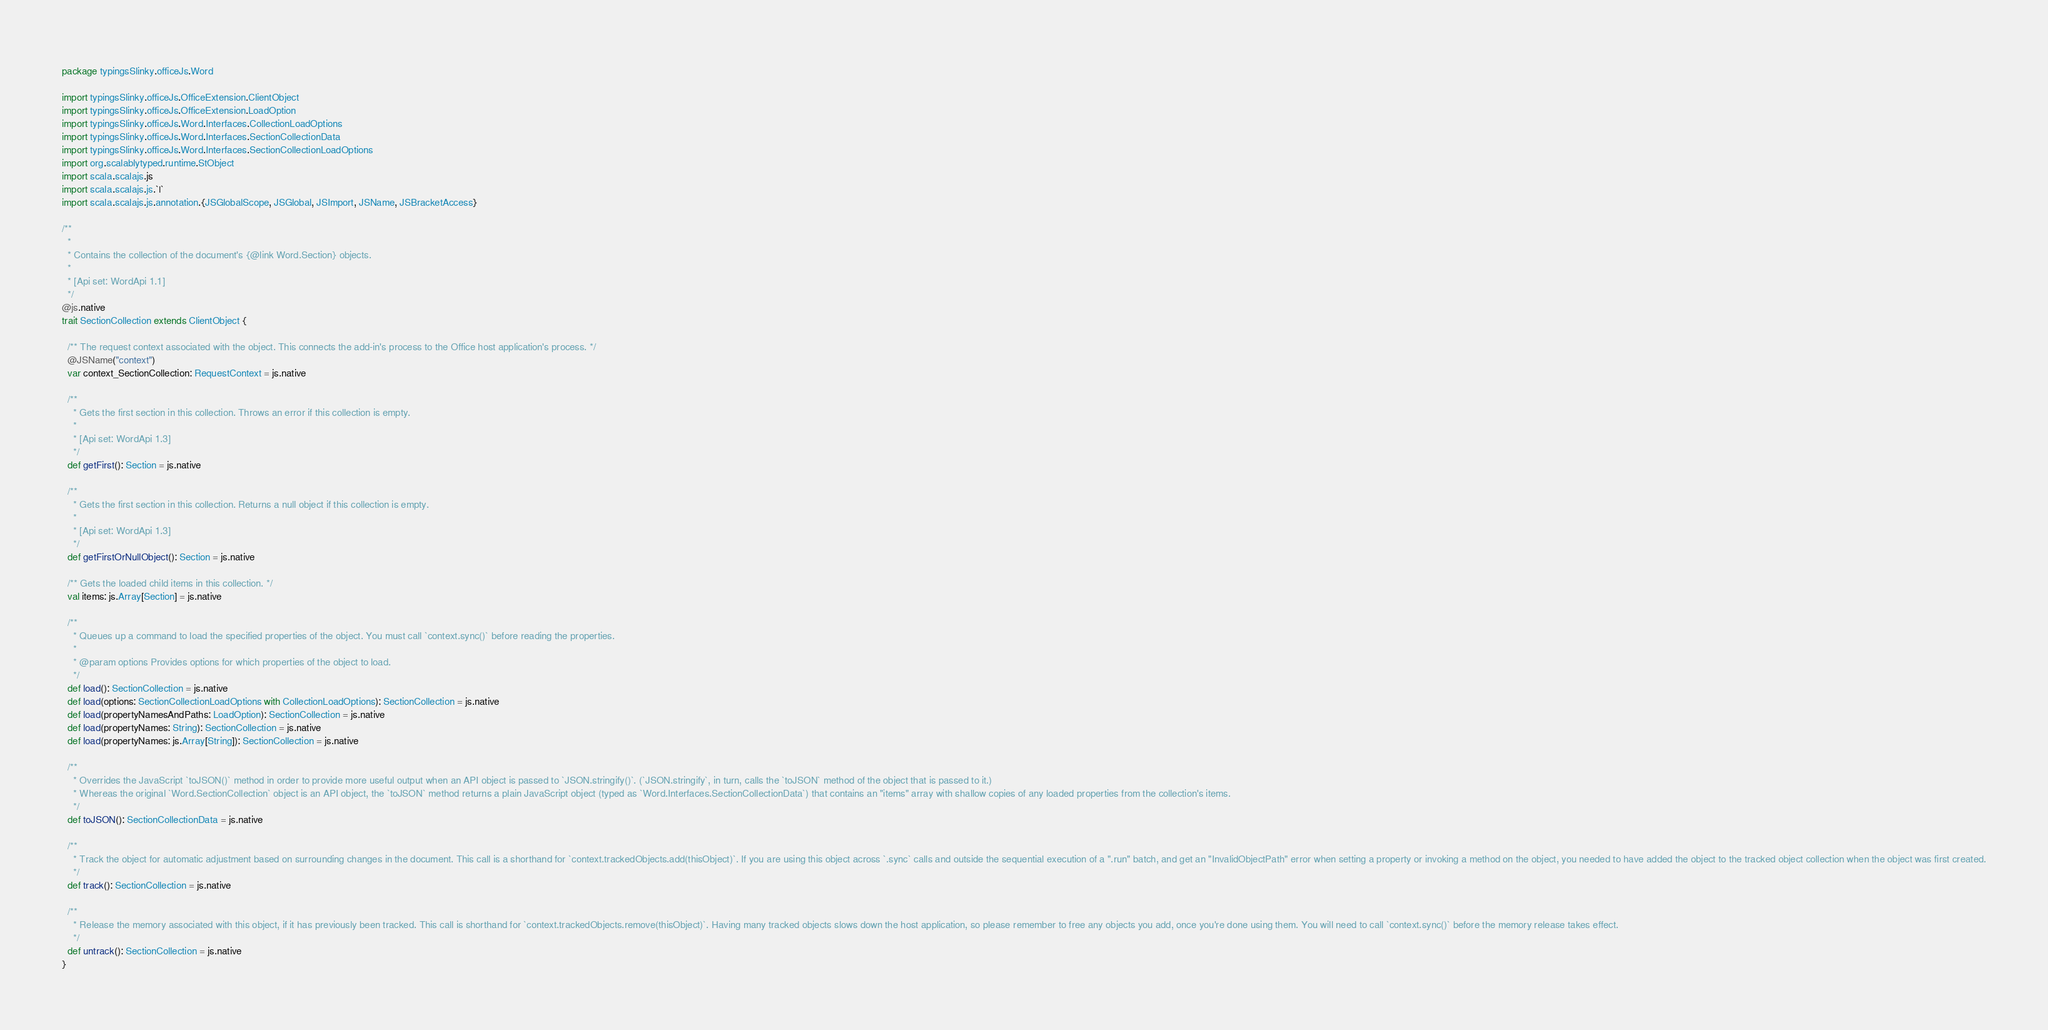Convert code to text. <code><loc_0><loc_0><loc_500><loc_500><_Scala_>package typingsSlinky.officeJs.Word

import typingsSlinky.officeJs.OfficeExtension.ClientObject
import typingsSlinky.officeJs.OfficeExtension.LoadOption
import typingsSlinky.officeJs.Word.Interfaces.CollectionLoadOptions
import typingsSlinky.officeJs.Word.Interfaces.SectionCollectionData
import typingsSlinky.officeJs.Word.Interfaces.SectionCollectionLoadOptions
import org.scalablytyped.runtime.StObject
import scala.scalajs.js
import scala.scalajs.js.`|`
import scala.scalajs.js.annotation.{JSGlobalScope, JSGlobal, JSImport, JSName, JSBracketAccess}

/**
  *
  * Contains the collection of the document's {@link Word.Section} objects.
  *
  * [Api set: WordApi 1.1]
  */
@js.native
trait SectionCollection extends ClientObject {
  
  /** The request context associated with the object. This connects the add-in's process to the Office host application's process. */
  @JSName("context")
  var context_SectionCollection: RequestContext = js.native
  
  /**
    * Gets the first section in this collection. Throws an error if this collection is empty.
    *
    * [Api set: WordApi 1.3]
    */
  def getFirst(): Section = js.native
  
  /**
    * Gets the first section in this collection. Returns a null object if this collection is empty.
    *
    * [Api set: WordApi 1.3]
    */
  def getFirstOrNullObject(): Section = js.native
  
  /** Gets the loaded child items in this collection. */
  val items: js.Array[Section] = js.native
  
  /**
    * Queues up a command to load the specified properties of the object. You must call `context.sync()` before reading the properties.
    *
    * @param options Provides options for which properties of the object to load.
    */
  def load(): SectionCollection = js.native
  def load(options: SectionCollectionLoadOptions with CollectionLoadOptions): SectionCollection = js.native
  def load(propertyNamesAndPaths: LoadOption): SectionCollection = js.native
  def load(propertyNames: String): SectionCollection = js.native
  def load(propertyNames: js.Array[String]): SectionCollection = js.native
  
  /**
    * Overrides the JavaScript `toJSON()` method in order to provide more useful output when an API object is passed to `JSON.stringify()`. (`JSON.stringify`, in turn, calls the `toJSON` method of the object that is passed to it.)
    * Whereas the original `Word.SectionCollection` object is an API object, the `toJSON` method returns a plain JavaScript object (typed as `Word.Interfaces.SectionCollectionData`) that contains an "items" array with shallow copies of any loaded properties from the collection's items.
    */
  def toJSON(): SectionCollectionData = js.native
  
  /**
    * Track the object for automatic adjustment based on surrounding changes in the document. This call is a shorthand for `context.trackedObjects.add(thisObject)`. If you are using this object across `.sync` calls and outside the sequential execution of a ".run" batch, and get an "InvalidObjectPath" error when setting a property or invoking a method on the object, you needed to have added the object to the tracked object collection when the object was first created.
    */
  def track(): SectionCollection = js.native
  
  /**
    * Release the memory associated with this object, if it has previously been tracked. This call is shorthand for `context.trackedObjects.remove(thisObject)`. Having many tracked objects slows down the host application, so please remember to free any objects you add, once you're done using them. You will need to call `context.sync()` before the memory release takes effect.
    */
  def untrack(): SectionCollection = js.native
}
</code> 